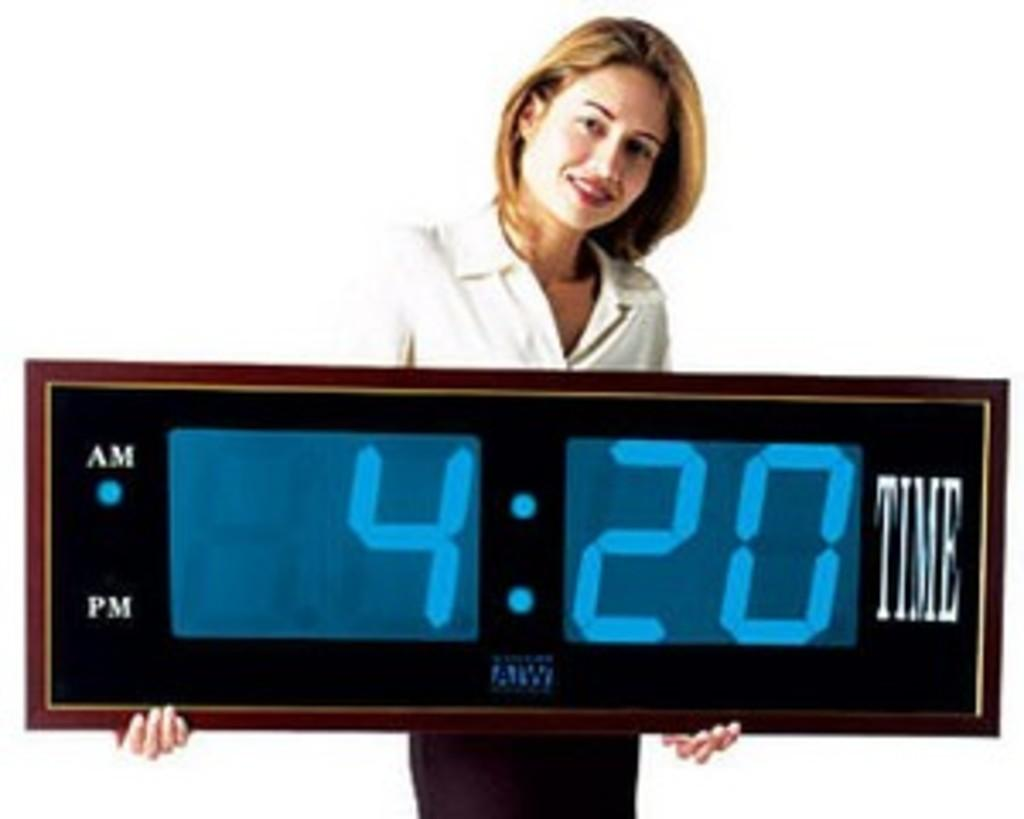Provide a one-sentence caption for the provided image. the time 4:20 is on an alarm clock. 